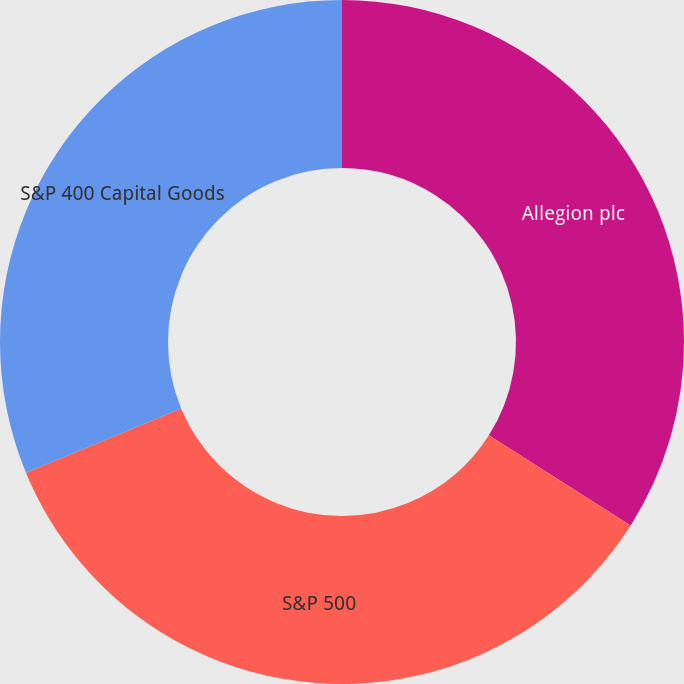Convert chart to OTSL. <chart><loc_0><loc_0><loc_500><loc_500><pie_chart><fcel>Allegion plc<fcel>S&P 500<fcel>S&P 400 Capital Goods<nl><fcel>34.01%<fcel>34.75%<fcel>31.24%<nl></chart> 